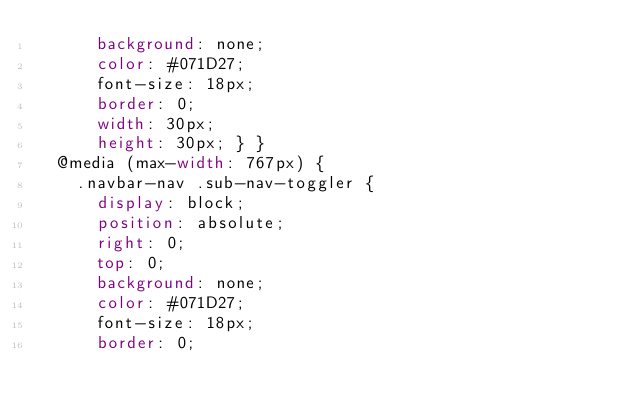Convert code to text. <code><loc_0><loc_0><loc_500><loc_500><_CSS_>      background: none;
      color: #071D27;
      font-size: 18px;
      border: 0;
      width: 30px;
      height: 30px; } }
  @media (max-width: 767px) {
    .navbar-nav .sub-nav-toggler {
      display: block;
      position: absolute;
      right: 0;
      top: 0;
      background: none;
      color: #071D27;
      font-size: 18px;
      border: 0;</code> 